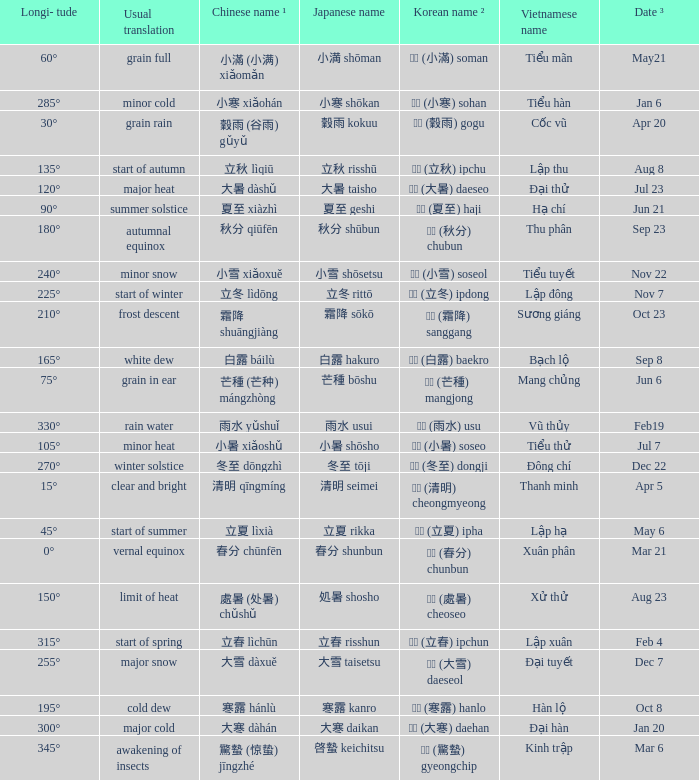Which Longi- tude is on jun 6? 75°. 